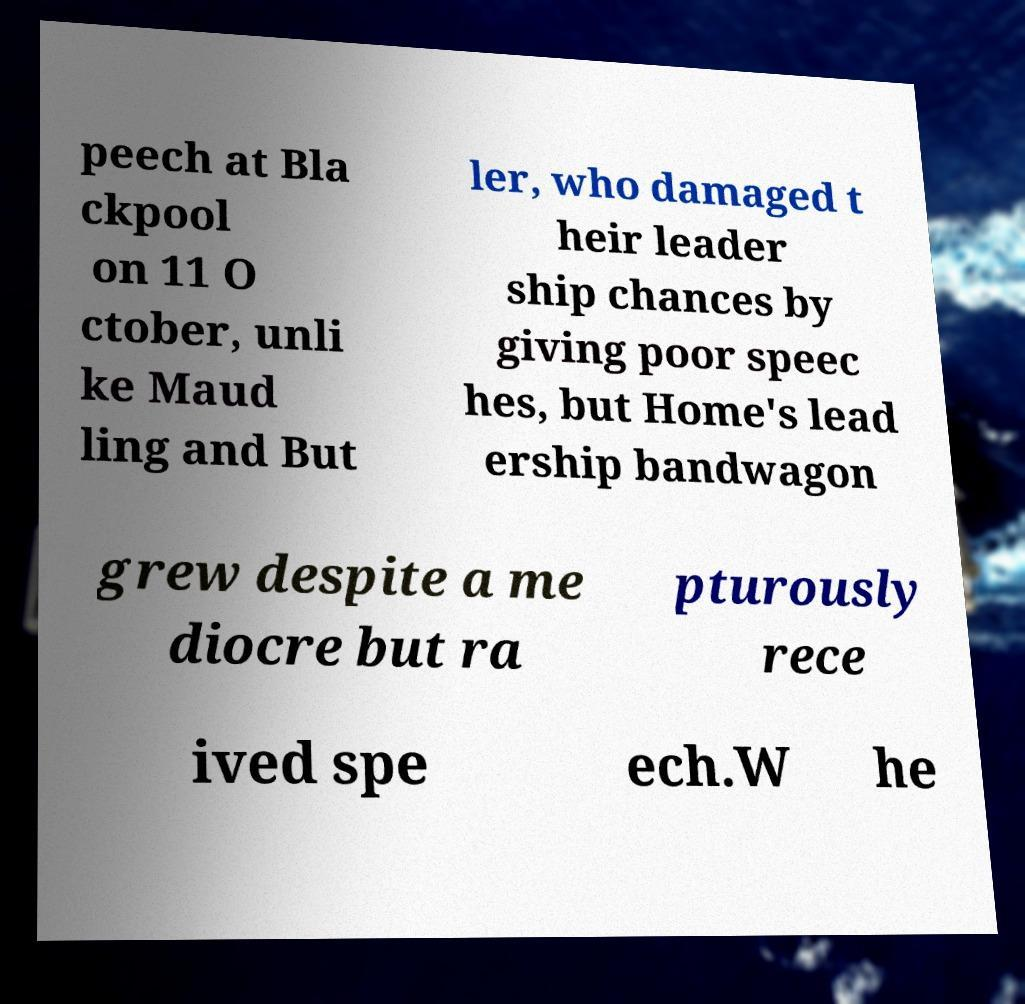There's text embedded in this image that I need extracted. Can you transcribe it verbatim? peech at Bla ckpool on 11 O ctober, unli ke Maud ling and But ler, who damaged t heir leader ship chances by giving poor speec hes, but Home's lead ership bandwagon grew despite a me diocre but ra pturously rece ived spe ech.W he 